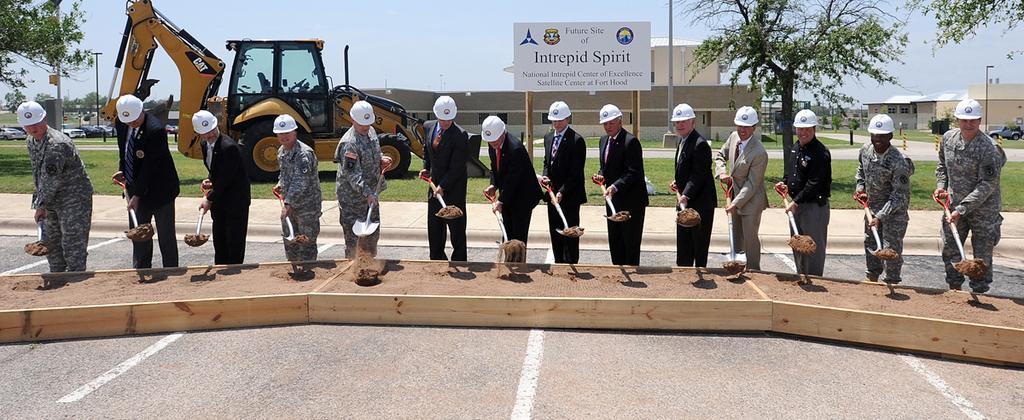Could you give a brief overview of what you see in this image? In this image, we can see a group of people wearing clothes and holding a shovels with their hands. There is a vehicle and building in the middle of the image. There is a tree in the top right of the image. There is a board and sky at the top of the image. 